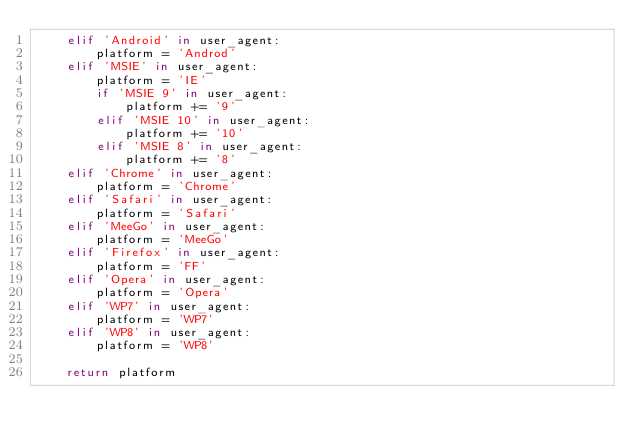<code> <loc_0><loc_0><loc_500><loc_500><_Python_>    elif 'Android' in user_agent:
        platform = 'Androd'
    elif 'MSIE' in user_agent:
        platform = 'IE'
        if 'MSIE 9' in user_agent:
            platform += '9'
        elif 'MSIE 10' in user_agent:
            platform += '10'
        elif 'MSIE 8' in user_agent:
            platform += '8'
    elif 'Chrome' in user_agent:
        platform = 'Chrome'
    elif 'Safari' in user_agent:
        platform = 'Safari'
    elif 'MeeGo' in user_agent:
        platform = 'MeeGo'
    elif 'Firefox' in user_agent:
        platform = 'FF'
    elif 'Opera' in user_agent:
        platform = 'Opera'
    elif 'WP7' in user_agent:
        platform = 'WP7'
    elif 'WP8' in user_agent:
        platform = 'WP8'
    
    return platform</code> 